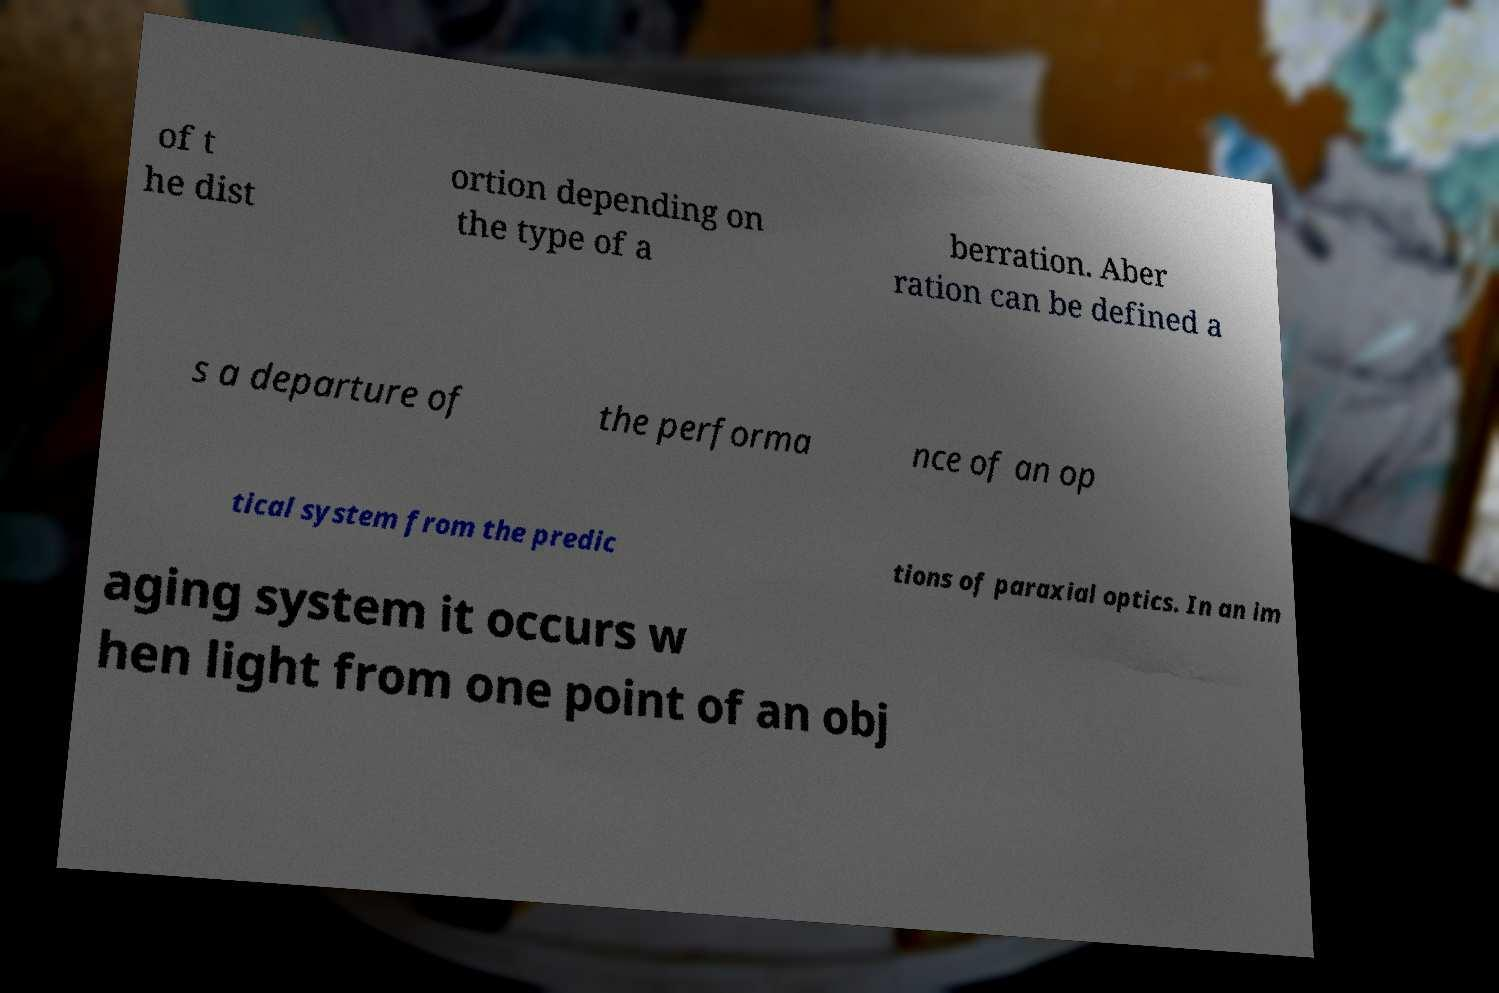There's text embedded in this image that I need extracted. Can you transcribe it verbatim? of t he dist ortion depending on the type of a berration. Aber ration can be defined a s a departure of the performa nce of an op tical system from the predic tions of paraxial optics. In an im aging system it occurs w hen light from one point of an obj 